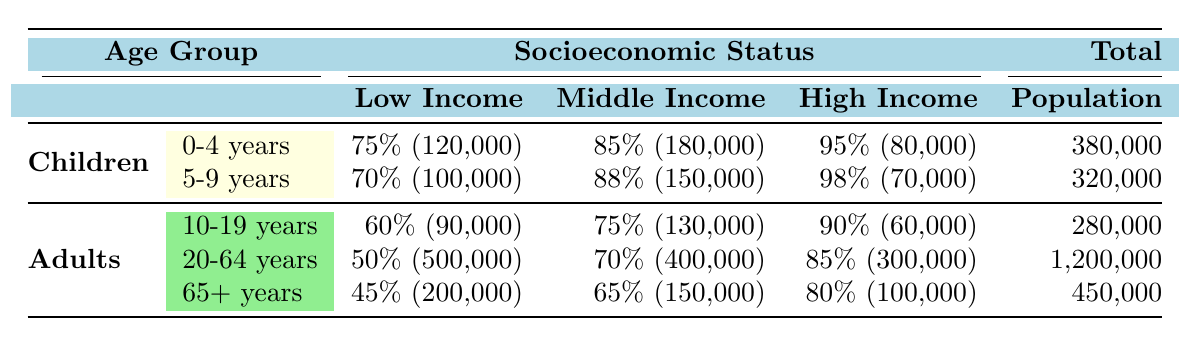What is the vaccination coverage rate for low-income children aged 0-4 years? The table states that for children aged 0-4 years under low income, the coverage rate is 75%.
Answer: 75% Which age group has the highest vaccination coverage rate among middle-income individuals? In the table, we can see that for middle income, children aged 5-9 years have a coverage rate of 88%, which is higher than the rates of 75% (10-19 years), 70% (20-64 years), and 65% (65 years and older).
Answer: 5-9 years How many adults aged 20-64 years are included in the vaccination coverage data? The table shows that for the age group 20-64 years, the population count is 400,000.
Answer: 400,000 Is the vaccination coverage rate for high-income adults aged 10-19 years greater than the coverage rate for low-income adults in the same age group? Yes, the coverage rate for high-income adults aged 10-19 years is 90%, which is greater than the low-income rate of 60%.
Answer: Yes What is the average vaccination coverage rate for low-income individuals across all age groups? To calculate the average, we will sum the coverage rates for low-income individuals: (75 + 70 + 60 + 50 + 45) = 300 and divide by the number of age groups (5), resulting in an average of 300 / 5 = 60.
Answer: 60 Which socioeconomic group has the highest total population among adults aged 20-64 years? In the table, the total population count for low-income adults aged 20-64 years is 500,000, which is greater than the counts for middle income (400,000) and high income (300,000).
Answer: Low Income What is the combined population count for children aged 0-4 years and 5-9 years? The combined population for children aged 0-4 years is 120,000 and for 5-9 years is 100,000. Adding these values gives us 120,000 + 100,000 = 220,000.
Answer: 220,000 Does the vaccination coverage for high-income individuals in the age group 65 years and older meet the average coverage rate of low-income groups? Yes, the coverage rate for high-income individuals aged 65+ years is 80%, which is above the average low-income coverage rate of 60%.
Answer: Yes What is the difference in vaccination coverage rates between middle-income adults aged 20-64 years and low-income adults in the same age group? The coverage rate for low-income adults aged 20-64 years is 50%, while for middle-income adults in the same age group it is 70%. The difference is 70 - 50 = 20.
Answer: 20 